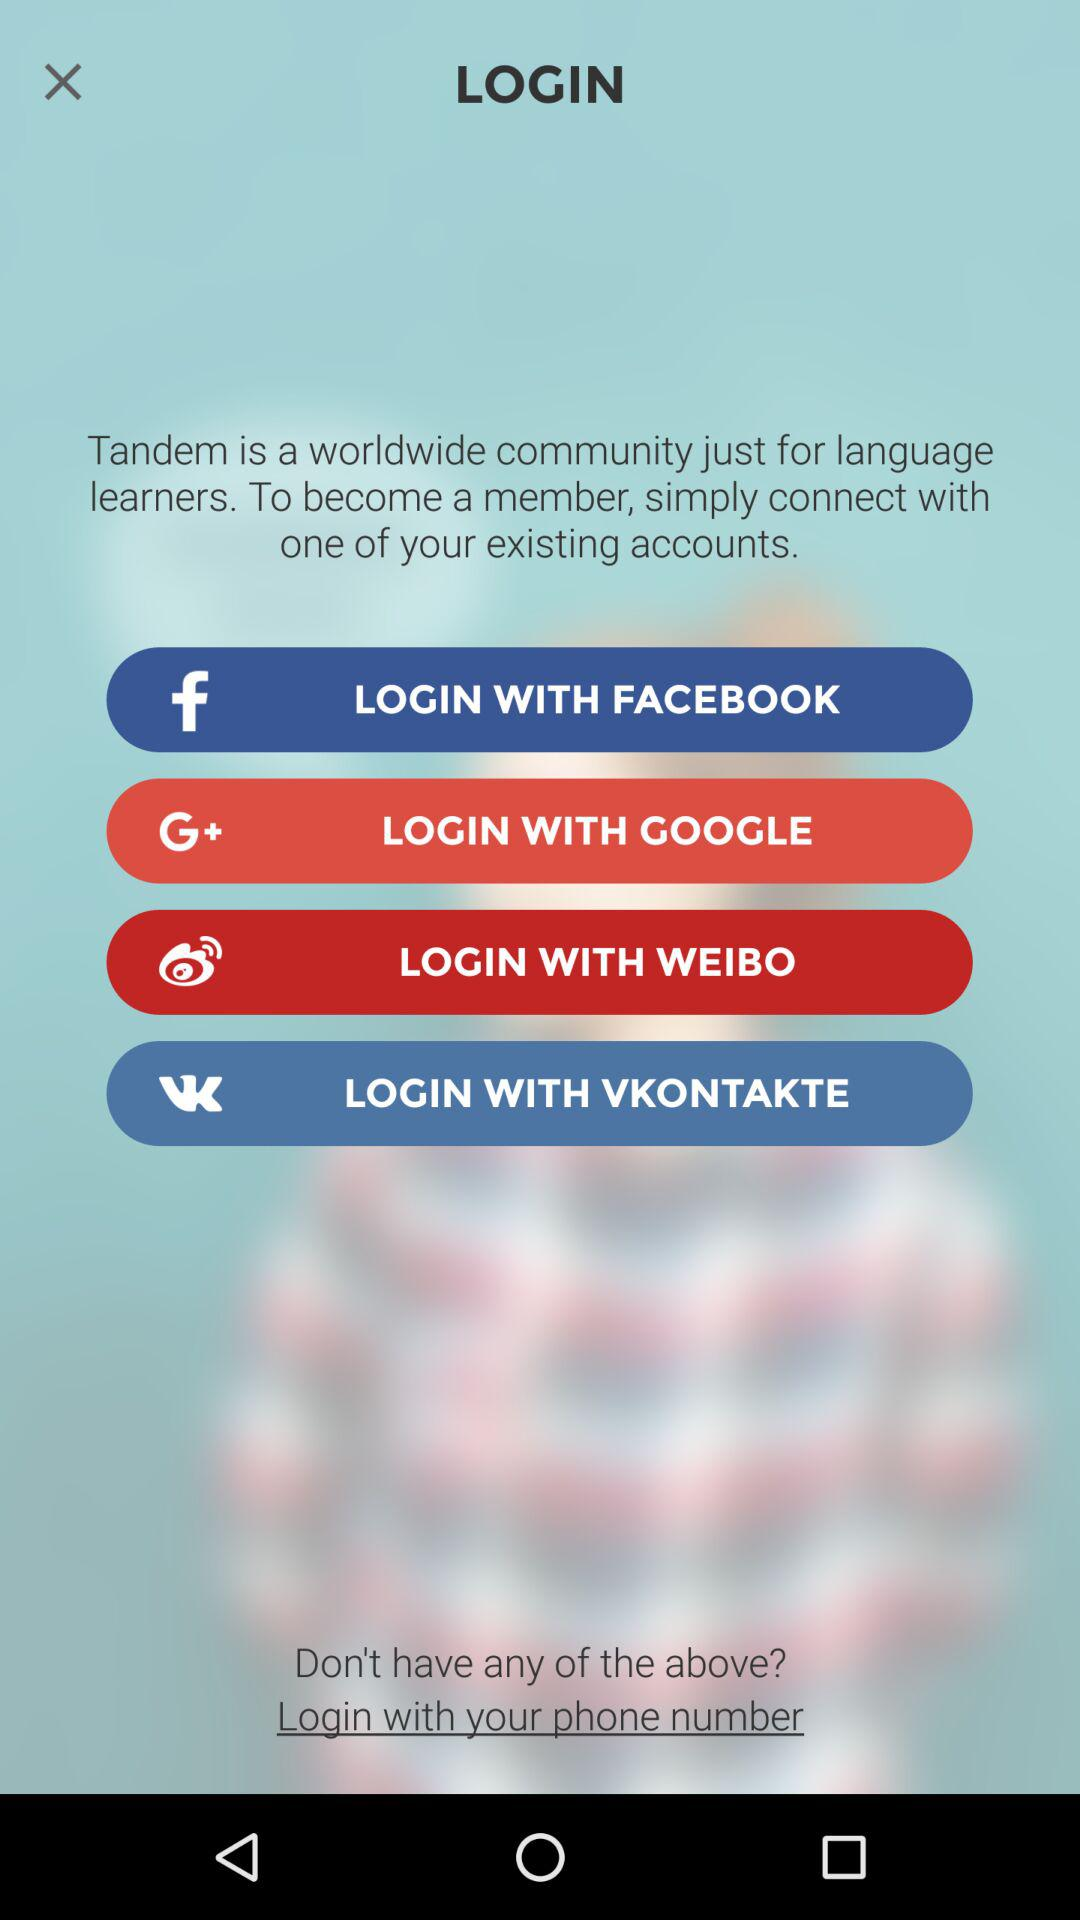What is the login option if I don't have an existing account? The login options are "FACEBOOK", "GOOGLE", "WEIBO", "VKONTAKTE" and "phone number". 